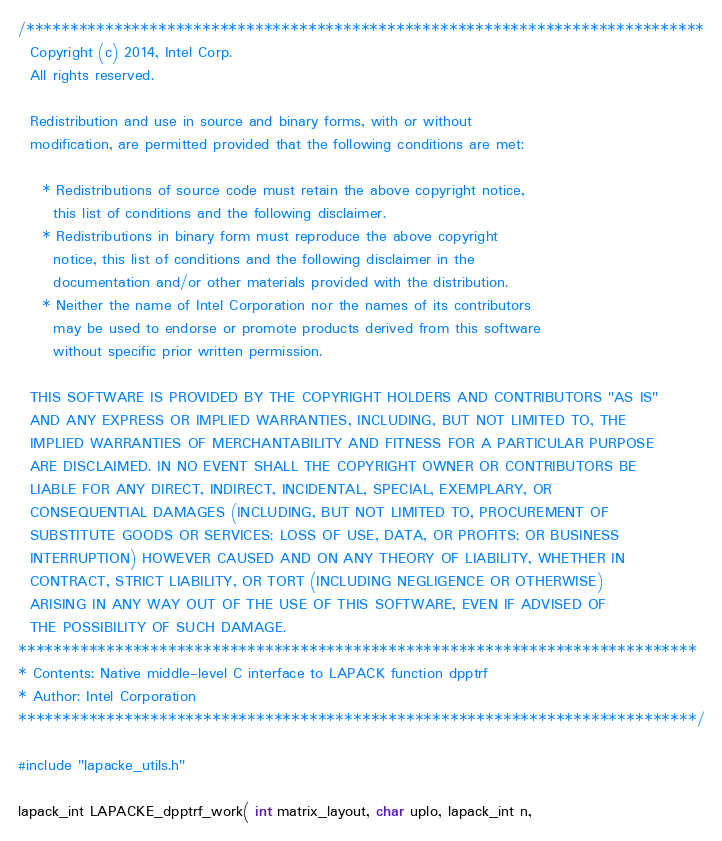Convert code to text. <code><loc_0><loc_0><loc_500><loc_500><_C_>/*****************************************************************************
  Copyright (c) 2014, Intel Corp.
  All rights reserved.

  Redistribution and use in source and binary forms, with or without
  modification, are permitted provided that the following conditions are met:

    * Redistributions of source code must retain the above copyright notice,
      this list of conditions and the following disclaimer.
    * Redistributions in binary form must reproduce the above copyright
      notice, this list of conditions and the following disclaimer in the
      documentation and/or other materials provided with the distribution.
    * Neither the name of Intel Corporation nor the names of its contributors
      may be used to endorse or promote products derived from this software
      without specific prior written permission.

  THIS SOFTWARE IS PROVIDED BY THE COPYRIGHT HOLDERS AND CONTRIBUTORS "AS IS"
  AND ANY EXPRESS OR IMPLIED WARRANTIES, INCLUDING, BUT NOT LIMITED TO, THE
  IMPLIED WARRANTIES OF MERCHANTABILITY AND FITNESS FOR A PARTICULAR PURPOSE
  ARE DISCLAIMED. IN NO EVENT SHALL THE COPYRIGHT OWNER OR CONTRIBUTORS BE
  LIABLE FOR ANY DIRECT, INDIRECT, INCIDENTAL, SPECIAL, EXEMPLARY, OR
  CONSEQUENTIAL DAMAGES (INCLUDING, BUT NOT LIMITED TO, PROCUREMENT OF
  SUBSTITUTE GOODS OR SERVICES; LOSS OF USE, DATA, OR PROFITS; OR BUSINESS
  INTERRUPTION) HOWEVER CAUSED AND ON ANY THEORY OF LIABILITY, WHETHER IN
  CONTRACT, STRICT LIABILITY, OR TORT (INCLUDING NEGLIGENCE OR OTHERWISE)
  ARISING IN ANY WAY OUT OF THE USE OF THIS SOFTWARE, EVEN IF ADVISED OF
  THE POSSIBILITY OF SUCH DAMAGE.
*****************************************************************************
* Contents: Native middle-level C interface to LAPACK function dpptrf
* Author: Intel Corporation
*****************************************************************************/

#include "lapacke_utils.h"

lapack_int LAPACKE_dpptrf_work( int matrix_layout, char uplo, lapack_int n,</code> 